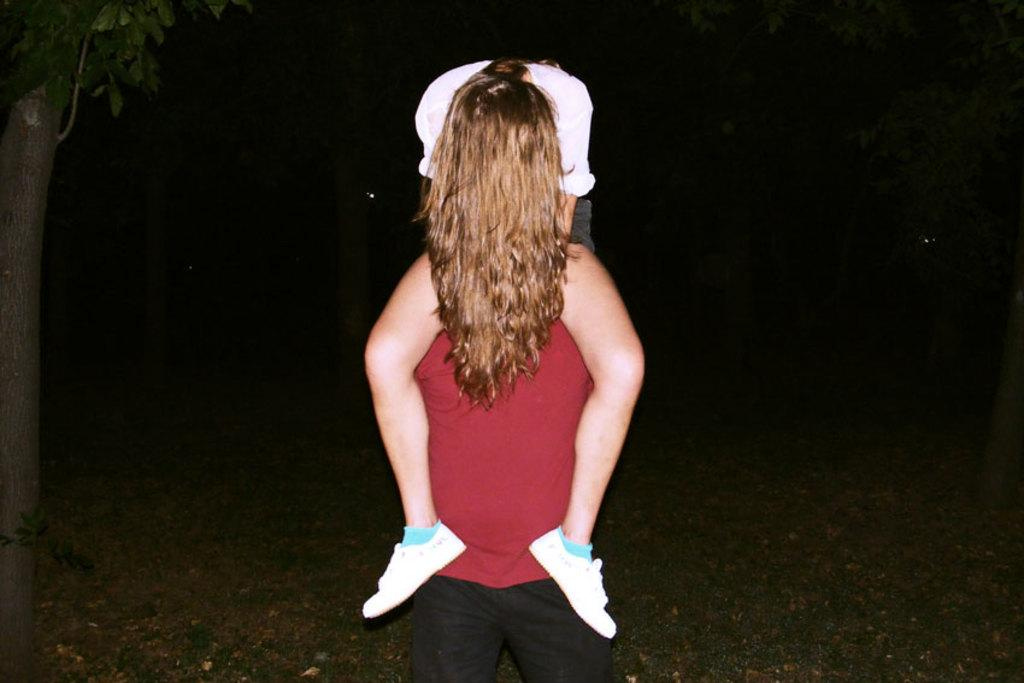What is happening in the center of the image? There is a lady sitting on a person in the center of the image. What can be seen in the background of the image? There are trees in the background of the image. What is visible at the bottom of the image? There is ground visible at the bottom of the image. How many eggs are being transported in the harbor in the image? There is no harbor or eggs present in the image. Is there a goat visible in the image? No, there is no goat present in the image. 